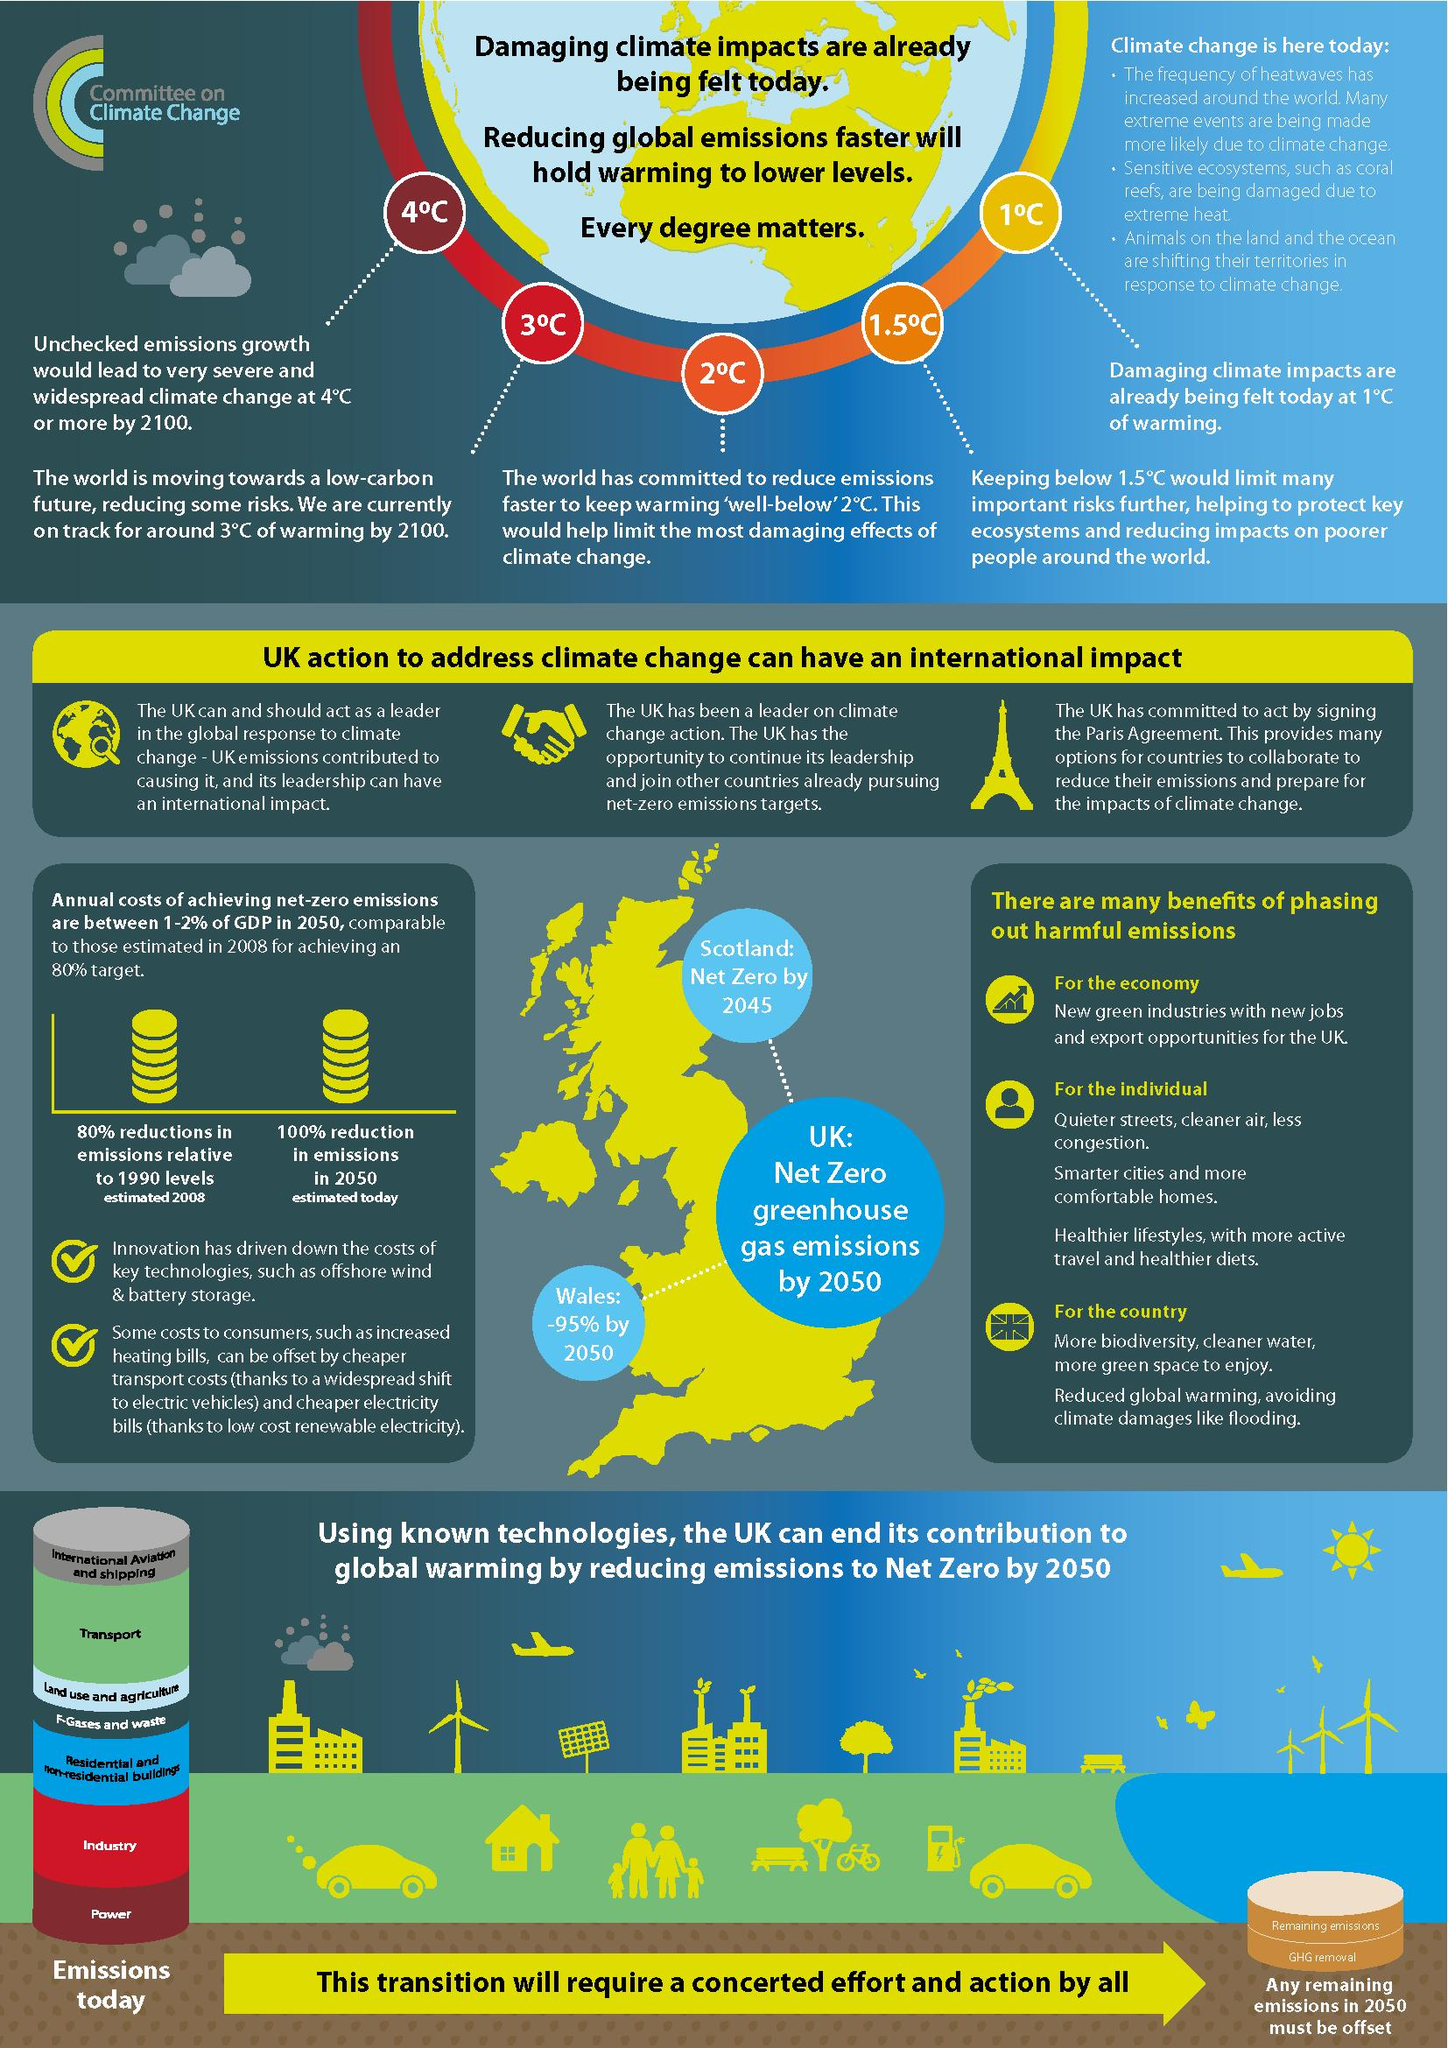Specify some key components in this picture. If greenhouse gases were kept in check until 2100, the difference in temperature in degrees Celsius would be significantly lower than if they were not. The predicted growth in climate change by 2100, if no precautions are taken, is projected to be 4 degrees Celsius. Scotland, Wales, and the UK as a whole have the potential to significantly reduce greenhouse gas emissions to more than 90% by 2050, according to recent research. 